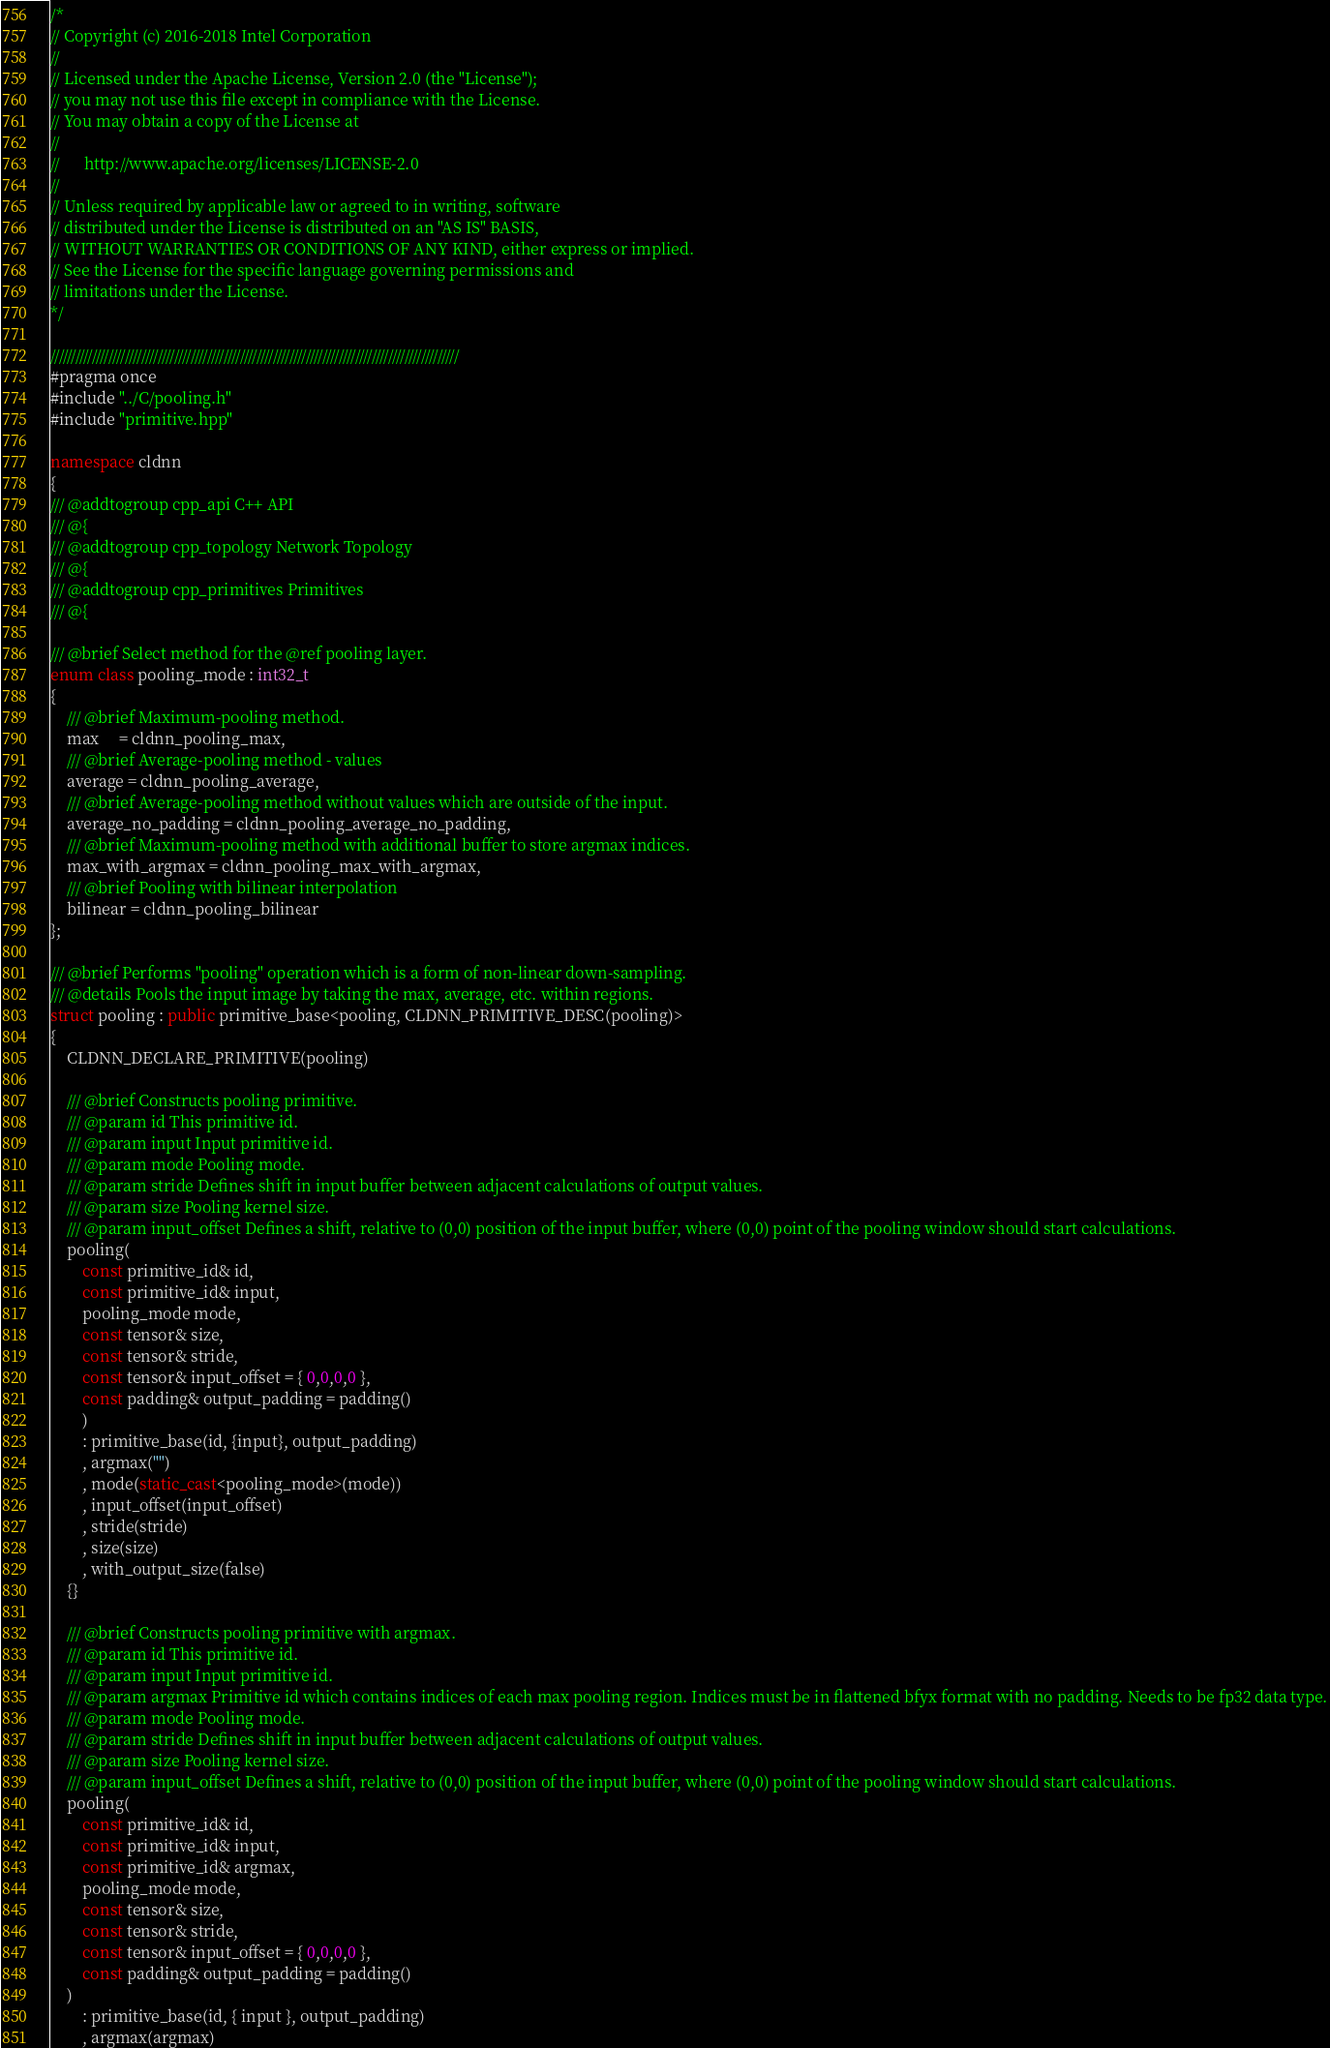<code> <loc_0><loc_0><loc_500><loc_500><_C++_>/*
// Copyright (c) 2016-2018 Intel Corporation
//
// Licensed under the Apache License, Version 2.0 (the "License");
// you may not use this file except in compliance with the License.
// You may obtain a copy of the License at
//
//      http://www.apache.org/licenses/LICENSE-2.0
//
// Unless required by applicable law or agreed to in writing, software
// distributed under the License is distributed on an "AS IS" BASIS,
// WITHOUT WARRANTIES OR CONDITIONS OF ANY KIND, either express or implied.
// See the License for the specific language governing permissions and
// limitations under the License.
*/

///////////////////////////////////////////////////////////////////////////////////////////////////
#pragma once
#include "../C/pooling.h"
#include "primitive.hpp"

namespace cldnn
{
/// @addtogroup cpp_api C++ API
/// @{
/// @addtogroup cpp_topology Network Topology
/// @{
/// @addtogroup cpp_primitives Primitives
/// @{

/// @brief Select method for the @ref pooling layer.
enum class pooling_mode : int32_t
{
    /// @brief Maximum-pooling method.
    max     = cldnn_pooling_max,
    /// @brief Average-pooling method - values 
    average = cldnn_pooling_average,
    /// @brief Average-pooling method without values which are outside of the input.
    average_no_padding = cldnn_pooling_average_no_padding,
    /// @brief Maximum-pooling method with additional buffer to store argmax indices.
    max_with_argmax = cldnn_pooling_max_with_argmax,
    /// @brief Pooling with bilinear interpolation
    bilinear = cldnn_pooling_bilinear
};

/// @brief Performs "pooling" operation which is a form of non-linear down-sampling.
/// @details Pools the input image by taking the max, average, etc. within regions.
struct pooling : public primitive_base<pooling, CLDNN_PRIMITIVE_DESC(pooling)>
{
    CLDNN_DECLARE_PRIMITIVE(pooling)

    /// @brief Constructs pooling primitive.
    /// @param id This primitive id.
    /// @param input Input primitive id.
    /// @param mode Pooling mode.
    /// @param stride Defines shift in input buffer between adjacent calculations of output values.
    /// @param size Pooling kernel size.
    /// @param input_offset Defines a shift, relative to (0,0) position of the input buffer, where (0,0) point of the pooling window should start calculations.
    pooling(
        const primitive_id& id,
        const primitive_id& input,
        pooling_mode mode,
        const tensor& size,
        const tensor& stride,
        const tensor& input_offset = { 0,0,0,0 },
        const padding& output_padding = padding()
        )
        : primitive_base(id, {input}, output_padding)
        , argmax("")
        , mode(static_cast<pooling_mode>(mode))
        , input_offset(input_offset)
        , stride(stride)
        , size(size)
        , with_output_size(false)
    {}

    /// @brief Constructs pooling primitive with argmax.
    /// @param id This primitive id.
    /// @param input Input primitive id.
    /// @param argmax Primitive id which contains indices of each max pooling region. Indices must be in flattened bfyx format with no padding. Needs to be fp32 data type.
    /// @param mode Pooling mode.
    /// @param stride Defines shift in input buffer between adjacent calculations of output values.
    /// @param size Pooling kernel size.
    /// @param input_offset Defines a shift, relative to (0,0) position of the input buffer, where (0,0) point of the pooling window should start calculations.
    pooling(
        const primitive_id& id,
        const primitive_id& input,
        const primitive_id& argmax,
        pooling_mode mode,
        const tensor& size,
        const tensor& stride,
        const tensor& input_offset = { 0,0,0,0 },
        const padding& output_padding = padding()
    )
        : primitive_base(id, { input }, output_padding)
        , argmax(argmax)</code> 